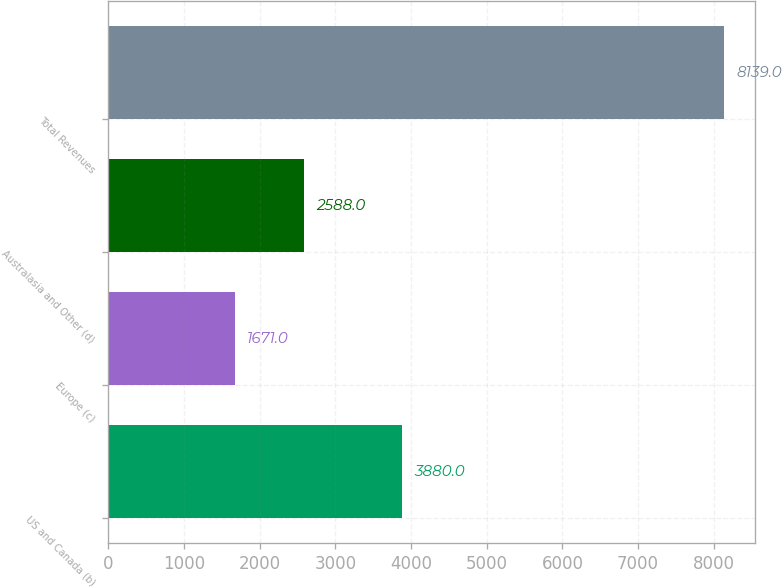Convert chart. <chart><loc_0><loc_0><loc_500><loc_500><bar_chart><fcel>US and Canada (b)<fcel>Europe (c)<fcel>Australasia and Other (d)<fcel>Total Revenues<nl><fcel>3880<fcel>1671<fcel>2588<fcel>8139<nl></chart> 